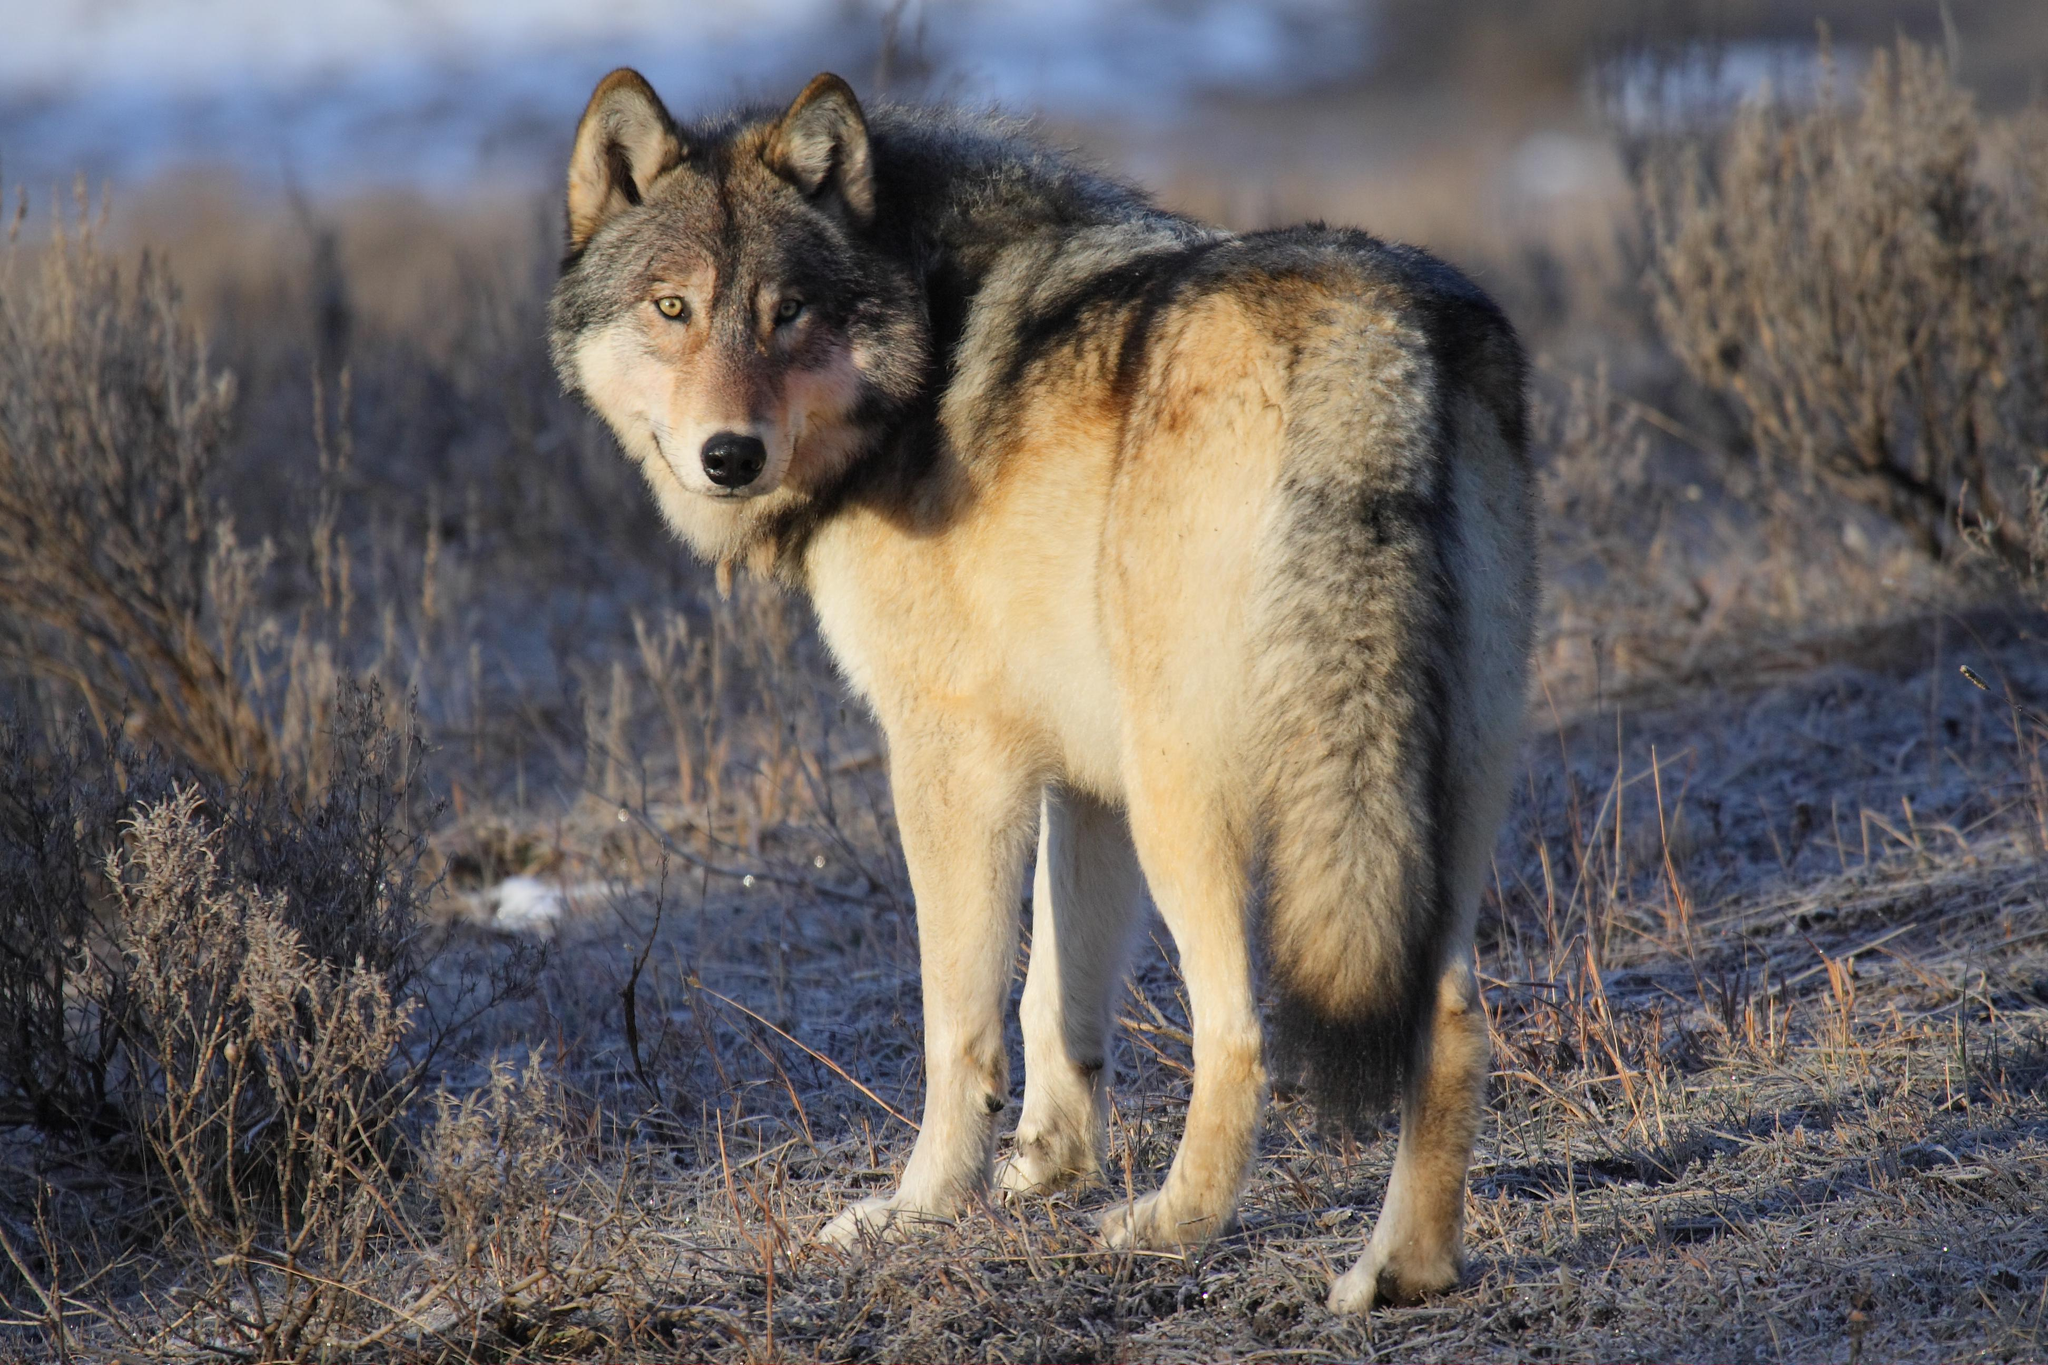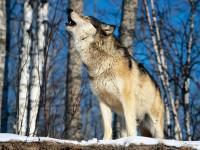The first image is the image on the left, the second image is the image on the right. Considering the images on both sides, is "Each image contains exactly one wolf, and one image features a wolf that is standing still and looking toward the camera." valid? Answer yes or no. Yes. The first image is the image on the left, the second image is the image on the right. Analyze the images presented: Is the assertion "The wolves are in a group in at least one picture." valid? Answer yes or no. No. 